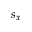<formula> <loc_0><loc_0><loc_500><loc_500>s _ { x }</formula> 